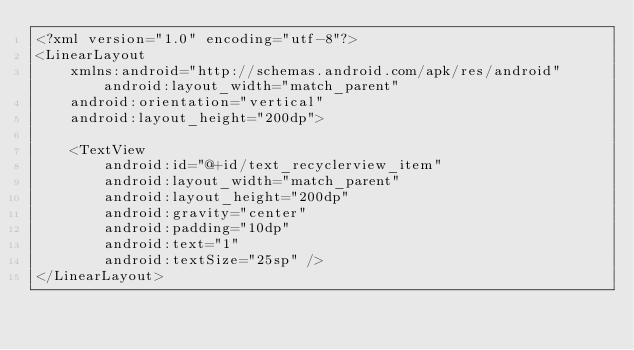Convert code to text. <code><loc_0><loc_0><loc_500><loc_500><_XML_><?xml version="1.0" encoding="utf-8"?>
<LinearLayout
    xmlns:android="http://schemas.android.com/apk/res/android" android:layout_width="match_parent"
    android:orientation="vertical"
    android:layout_height="200dp">

    <TextView
        android:id="@+id/text_recyclerview_item"
        android:layout_width="match_parent"
        android:layout_height="200dp"
        android:gravity="center"
        android:padding="10dp"
        android:text="1"
        android:textSize="25sp" />
</LinearLayout></code> 